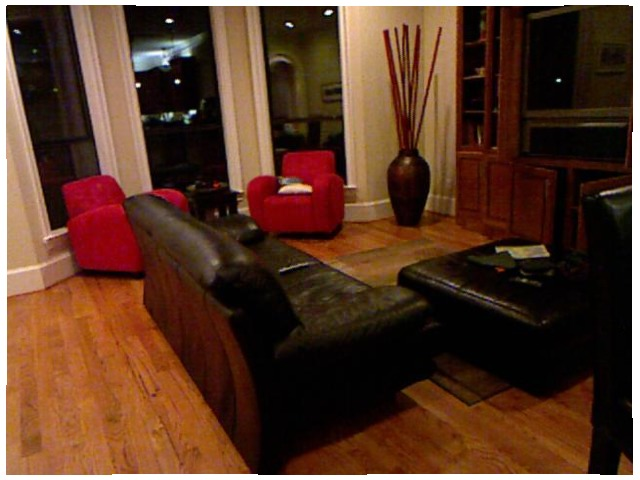<image>
Is the cushion on the sofa? No. The cushion is not positioned on the sofa. They may be near each other, but the cushion is not supported by or resting on top of the sofa. Is the pillow on the couch? No. The pillow is not positioned on the couch. They may be near each other, but the pillow is not supported by or resting on top of the couch. Is the vase on the table? No. The vase is not positioned on the table. They may be near each other, but the vase is not supported by or resting on top of the table. Is the big vase to the right of the sofa? Yes. From this viewpoint, the big vase is positioned to the right side relative to the sofa. 